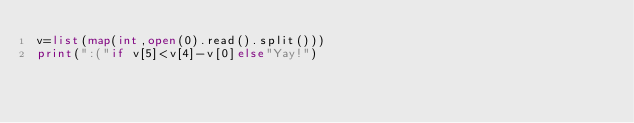<code> <loc_0><loc_0><loc_500><loc_500><_Python_>v=list(map(int,open(0).read().split()))
print(":("if v[5]<v[4]-v[0]else"Yay!")</code> 